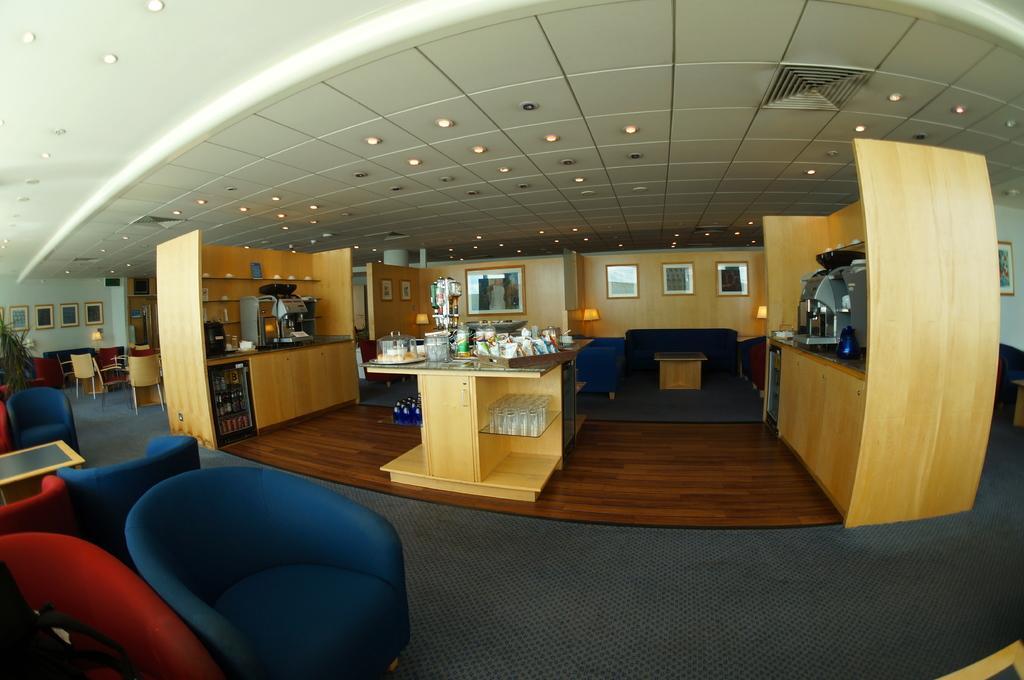In one or two sentences, can you explain what this image depicts? The picture is taken in a cafeteria or a restaurant. On the left there are couches and table. In the center of the picture there are tables, couches, coffee machines, glasses, jars, frames, lights and other utensils. On the right there couch and frames. On the left there are frames, chairs, couch, table and houseplant. 